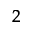<formula> <loc_0><loc_0><loc_500><loc_500>^ { 2 }</formula> 